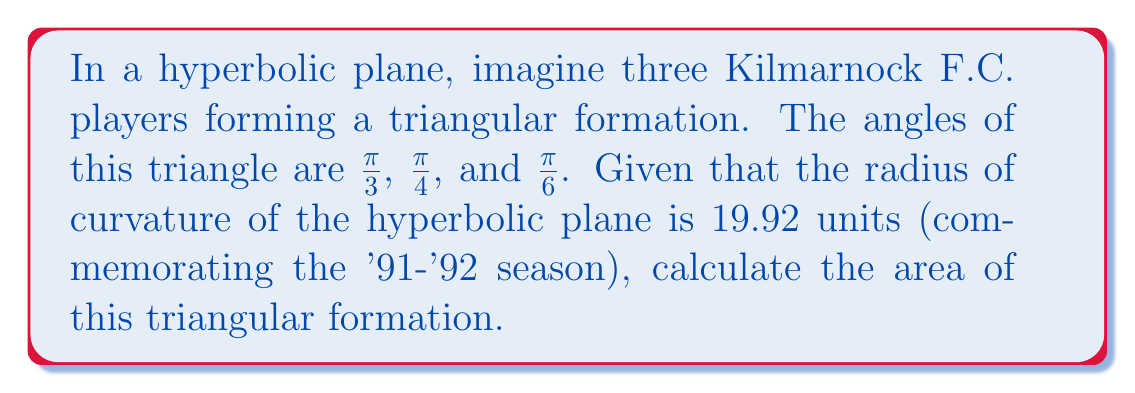What is the answer to this math problem? Let's approach this step-by-step:

1) In hyperbolic geometry, the area of a triangle is given by the formula:

   $$A = R^2(\pi - (\alpha + \beta + \gamma))$$

   where $R$ is the radius of curvature, and $\alpha$, $\beta$, and $\gamma$ are the angles of the triangle.

2) We're given that $R = 19.92$ and the angles are:
   $\alpha = \frac{\pi}{3}$, $\beta = \frac{\pi}{4}$, and $\gamma = \frac{\pi}{6}$

3) Let's sum the angles:
   $$\alpha + \beta + \gamma = \frac{\pi}{3} + \frac{\pi}{4} + \frac{\pi}{6}$$
   $$= \frac{4\pi}{12} + \frac{3\pi}{12} + \frac{2\pi}{12} = \frac{9\pi}{12} = \frac{3\pi}{4}$$

4) Now, let's substitute these values into our area formula:

   $$A = (19.92)^2(\pi - \frac{3\pi}{4})$$
   $$= 396.8064(\frac{\pi}{4})$$
   $$= 99.2016\pi$$

5) Therefore, the area of the triangular formation is $99.2016\pi$ square units.
Answer: $99.2016\pi$ square units 